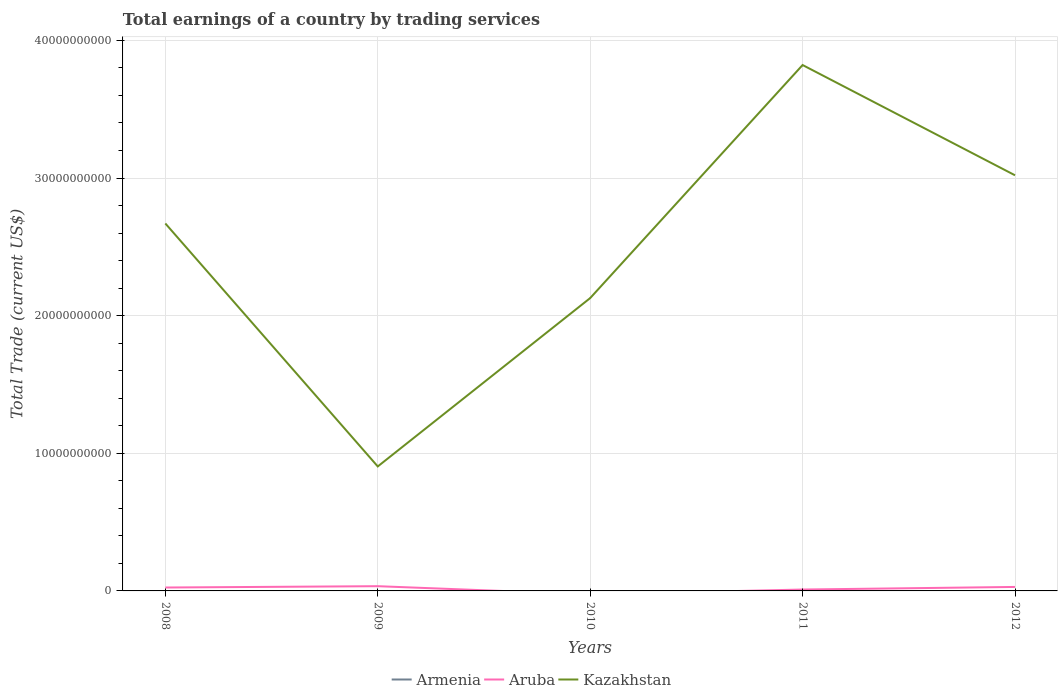How many different coloured lines are there?
Your response must be concise. 2. Across all years, what is the maximum total earnings in Kazakhstan?
Offer a terse response. 9.04e+09. What is the total total earnings in Kazakhstan in the graph?
Provide a short and direct response. -8.92e+09. What is the difference between the highest and the second highest total earnings in Aruba?
Give a very brief answer. 3.44e+08. What is the difference between the highest and the lowest total earnings in Aruba?
Give a very brief answer. 3. Is the total earnings in Aruba strictly greater than the total earnings in Kazakhstan over the years?
Offer a very short reply. Yes. How many years are there in the graph?
Your answer should be compact. 5. What is the difference between two consecutive major ticks on the Y-axis?
Offer a very short reply. 1.00e+1. Are the values on the major ticks of Y-axis written in scientific E-notation?
Provide a short and direct response. No. Does the graph contain any zero values?
Ensure brevity in your answer.  Yes. Does the graph contain grids?
Provide a succinct answer. Yes. How many legend labels are there?
Make the answer very short. 3. How are the legend labels stacked?
Give a very brief answer. Horizontal. What is the title of the graph?
Your answer should be compact. Total earnings of a country by trading services. What is the label or title of the Y-axis?
Your answer should be very brief. Total Trade (current US$). What is the Total Trade (current US$) in Aruba in 2008?
Your answer should be very brief. 2.48e+08. What is the Total Trade (current US$) of Kazakhstan in 2008?
Offer a very short reply. 2.67e+1. What is the Total Trade (current US$) of Armenia in 2009?
Keep it short and to the point. 0. What is the Total Trade (current US$) of Aruba in 2009?
Make the answer very short. 3.44e+08. What is the Total Trade (current US$) in Kazakhstan in 2009?
Provide a short and direct response. 9.04e+09. What is the Total Trade (current US$) of Kazakhstan in 2010?
Keep it short and to the point. 2.13e+1. What is the Total Trade (current US$) of Aruba in 2011?
Offer a very short reply. 1.01e+08. What is the Total Trade (current US$) of Kazakhstan in 2011?
Your answer should be compact. 3.82e+1. What is the Total Trade (current US$) of Aruba in 2012?
Make the answer very short. 2.89e+08. What is the Total Trade (current US$) in Kazakhstan in 2012?
Provide a short and direct response. 3.02e+1. Across all years, what is the maximum Total Trade (current US$) of Aruba?
Keep it short and to the point. 3.44e+08. Across all years, what is the maximum Total Trade (current US$) in Kazakhstan?
Ensure brevity in your answer.  3.82e+1. Across all years, what is the minimum Total Trade (current US$) of Kazakhstan?
Your answer should be very brief. 9.04e+09. What is the total Total Trade (current US$) of Armenia in the graph?
Give a very brief answer. 0. What is the total Total Trade (current US$) in Aruba in the graph?
Provide a short and direct response. 9.82e+08. What is the total Total Trade (current US$) of Kazakhstan in the graph?
Your answer should be compact. 1.25e+11. What is the difference between the Total Trade (current US$) in Aruba in 2008 and that in 2009?
Offer a very short reply. -9.66e+07. What is the difference between the Total Trade (current US$) of Kazakhstan in 2008 and that in 2009?
Ensure brevity in your answer.  1.77e+1. What is the difference between the Total Trade (current US$) of Kazakhstan in 2008 and that in 2010?
Ensure brevity in your answer.  5.42e+09. What is the difference between the Total Trade (current US$) in Aruba in 2008 and that in 2011?
Your answer should be compact. 1.47e+08. What is the difference between the Total Trade (current US$) in Kazakhstan in 2008 and that in 2011?
Offer a very short reply. -1.15e+1. What is the difference between the Total Trade (current US$) of Aruba in 2008 and that in 2012?
Ensure brevity in your answer.  -4.12e+07. What is the difference between the Total Trade (current US$) of Kazakhstan in 2008 and that in 2012?
Provide a succinct answer. -3.50e+09. What is the difference between the Total Trade (current US$) of Kazakhstan in 2009 and that in 2010?
Your response must be concise. -1.22e+1. What is the difference between the Total Trade (current US$) of Aruba in 2009 and that in 2011?
Offer a very short reply. 2.43e+08. What is the difference between the Total Trade (current US$) of Kazakhstan in 2009 and that in 2011?
Give a very brief answer. -2.92e+1. What is the difference between the Total Trade (current US$) of Aruba in 2009 and that in 2012?
Ensure brevity in your answer.  5.54e+07. What is the difference between the Total Trade (current US$) in Kazakhstan in 2009 and that in 2012?
Your response must be concise. -2.12e+1. What is the difference between the Total Trade (current US$) in Kazakhstan in 2010 and that in 2011?
Offer a terse response. -1.69e+1. What is the difference between the Total Trade (current US$) of Kazakhstan in 2010 and that in 2012?
Offer a terse response. -8.92e+09. What is the difference between the Total Trade (current US$) in Aruba in 2011 and that in 2012?
Provide a short and direct response. -1.88e+08. What is the difference between the Total Trade (current US$) of Kazakhstan in 2011 and that in 2012?
Offer a terse response. 8.01e+09. What is the difference between the Total Trade (current US$) of Aruba in 2008 and the Total Trade (current US$) of Kazakhstan in 2009?
Provide a succinct answer. -8.80e+09. What is the difference between the Total Trade (current US$) of Aruba in 2008 and the Total Trade (current US$) of Kazakhstan in 2010?
Offer a terse response. -2.10e+1. What is the difference between the Total Trade (current US$) in Aruba in 2008 and the Total Trade (current US$) in Kazakhstan in 2011?
Provide a succinct answer. -3.80e+1. What is the difference between the Total Trade (current US$) of Aruba in 2008 and the Total Trade (current US$) of Kazakhstan in 2012?
Your answer should be compact. -2.99e+1. What is the difference between the Total Trade (current US$) of Aruba in 2009 and the Total Trade (current US$) of Kazakhstan in 2010?
Provide a succinct answer. -2.09e+1. What is the difference between the Total Trade (current US$) in Aruba in 2009 and the Total Trade (current US$) in Kazakhstan in 2011?
Offer a terse response. -3.79e+1. What is the difference between the Total Trade (current US$) in Aruba in 2009 and the Total Trade (current US$) in Kazakhstan in 2012?
Ensure brevity in your answer.  -2.99e+1. What is the difference between the Total Trade (current US$) of Aruba in 2011 and the Total Trade (current US$) of Kazakhstan in 2012?
Offer a terse response. -3.01e+1. What is the average Total Trade (current US$) in Aruba per year?
Your response must be concise. 1.96e+08. What is the average Total Trade (current US$) in Kazakhstan per year?
Provide a short and direct response. 2.51e+1. In the year 2008, what is the difference between the Total Trade (current US$) in Aruba and Total Trade (current US$) in Kazakhstan?
Offer a terse response. -2.64e+1. In the year 2009, what is the difference between the Total Trade (current US$) in Aruba and Total Trade (current US$) in Kazakhstan?
Offer a terse response. -8.70e+09. In the year 2011, what is the difference between the Total Trade (current US$) of Aruba and Total Trade (current US$) of Kazakhstan?
Offer a terse response. -3.81e+1. In the year 2012, what is the difference between the Total Trade (current US$) in Aruba and Total Trade (current US$) in Kazakhstan?
Keep it short and to the point. -2.99e+1. What is the ratio of the Total Trade (current US$) in Aruba in 2008 to that in 2009?
Offer a very short reply. 0.72. What is the ratio of the Total Trade (current US$) in Kazakhstan in 2008 to that in 2009?
Offer a terse response. 2.95. What is the ratio of the Total Trade (current US$) in Kazakhstan in 2008 to that in 2010?
Ensure brevity in your answer.  1.25. What is the ratio of the Total Trade (current US$) of Aruba in 2008 to that in 2011?
Your response must be concise. 2.45. What is the ratio of the Total Trade (current US$) in Kazakhstan in 2008 to that in 2011?
Make the answer very short. 0.7. What is the ratio of the Total Trade (current US$) of Aruba in 2008 to that in 2012?
Keep it short and to the point. 0.86. What is the ratio of the Total Trade (current US$) of Kazakhstan in 2008 to that in 2012?
Ensure brevity in your answer.  0.88. What is the ratio of the Total Trade (current US$) of Kazakhstan in 2009 to that in 2010?
Give a very brief answer. 0.43. What is the ratio of the Total Trade (current US$) in Aruba in 2009 to that in 2011?
Your answer should be compact. 3.41. What is the ratio of the Total Trade (current US$) of Kazakhstan in 2009 to that in 2011?
Make the answer very short. 0.24. What is the ratio of the Total Trade (current US$) in Aruba in 2009 to that in 2012?
Your answer should be compact. 1.19. What is the ratio of the Total Trade (current US$) of Kazakhstan in 2009 to that in 2012?
Keep it short and to the point. 0.3. What is the ratio of the Total Trade (current US$) of Kazakhstan in 2010 to that in 2011?
Give a very brief answer. 0.56. What is the ratio of the Total Trade (current US$) of Kazakhstan in 2010 to that in 2012?
Keep it short and to the point. 0.7. What is the ratio of the Total Trade (current US$) in Aruba in 2011 to that in 2012?
Make the answer very short. 0.35. What is the ratio of the Total Trade (current US$) in Kazakhstan in 2011 to that in 2012?
Keep it short and to the point. 1.27. What is the difference between the highest and the second highest Total Trade (current US$) of Aruba?
Ensure brevity in your answer.  5.54e+07. What is the difference between the highest and the second highest Total Trade (current US$) in Kazakhstan?
Ensure brevity in your answer.  8.01e+09. What is the difference between the highest and the lowest Total Trade (current US$) of Aruba?
Ensure brevity in your answer.  3.44e+08. What is the difference between the highest and the lowest Total Trade (current US$) in Kazakhstan?
Offer a terse response. 2.92e+1. 